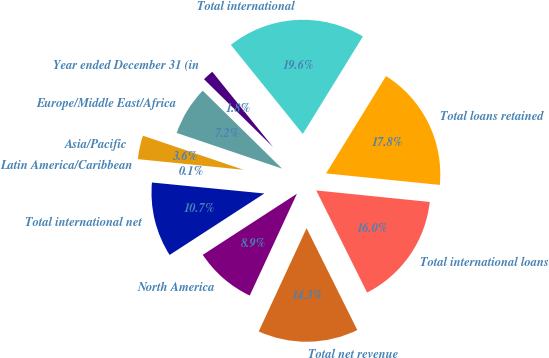<chart> <loc_0><loc_0><loc_500><loc_500><pie_chart><fcel>Year ended December 31 (in<fcel>Europe/Middle East/Africa<fcel>Asia/Pacific<fcel>Latin America/Caribbean<fcel>Total international net<fcel>North America<fcel>Total net revenue<fcel>Total international loans<fcel>Total loans retained<fcel>Total international<nl><fcel>1.83%<fcel>7.16%<fcel>3.6%<fcel>0.05%<fcel>10.71%<fcel>8.93%<fcel>14.26%<fcel>16.04%<fcel>17.82%<fcel>19.6%<nl></chart> 